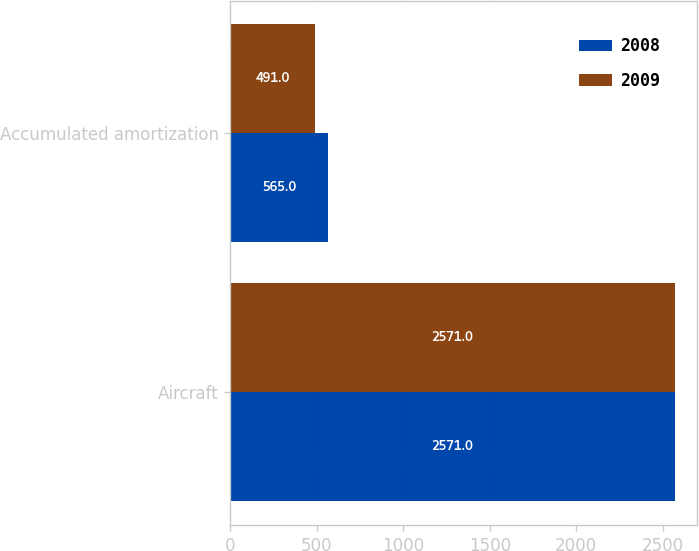Convert chart. <chart><loc_0><loc_0><loc_500><loc_500><stacked_bar_chart><ecel><fcel>Aircraft<fcel>Accumulated amortization<nl><fcel>2008<fcel>2571<fcel>565<nl><fcel>2009<fcel>2571<fcel>491<nl></chart> 